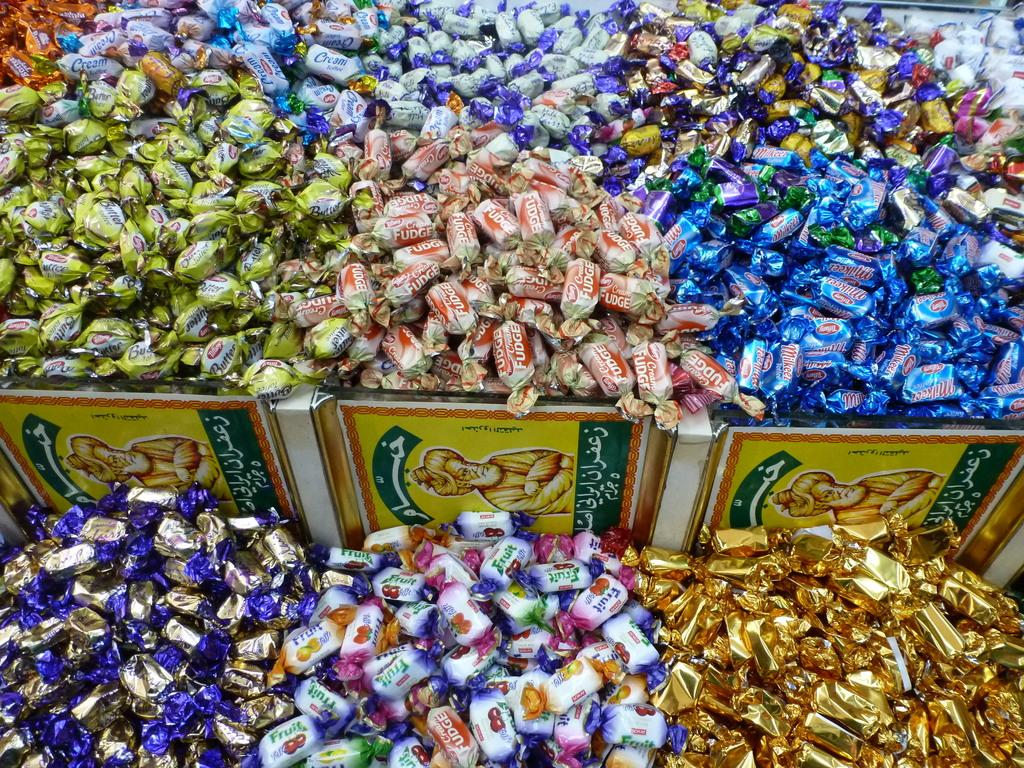What type of food can be seen in the image? There are chocolates in the image. What is located in the center of the image? There is a board in the center of the image. Who is the expert in the image? There is no expert present in the image; it only features chocolates and a board. What type of sugar can be seen in the image? There is no sugar visible in the image; it only features chocolates and a board. 